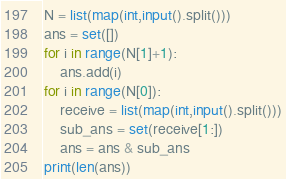Convert code to text. <code><loc_0><loc_0><loc_500><loc_500><_Python_>N = list(map(int,input().split()))
ans = set([])
for i in range(N[1]+1):
	ans.add(i)
for i in range(N[0]):
	receive = list(map(int,input().split()))
	sub_ans = set(receive[1:])
	ans = ans & sub_ans
print(len(ans))</code> 